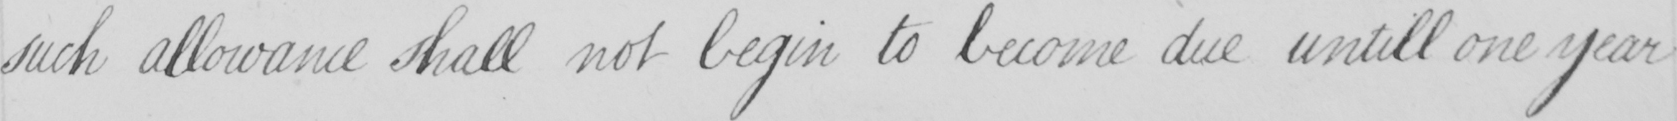Can you tell me what this handwritten text says? such allowance shall not begin to become due untill one year 